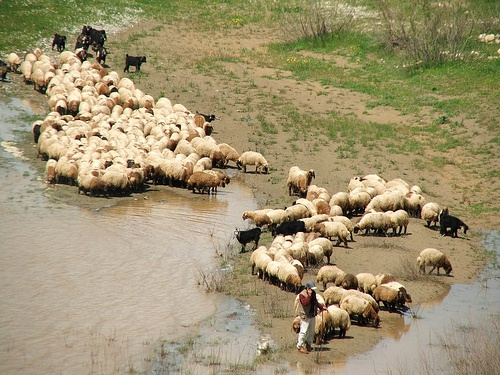Describe the objects in this image and their specific colors. I can see sheep in olive, tan, black, and beige tones, people in olive, black, gray, and ivory tones, sheep in olive, tan, and black tones, sheep in olive, black, and tan tones, and sheep in olive, black, and tan tones in this image. 